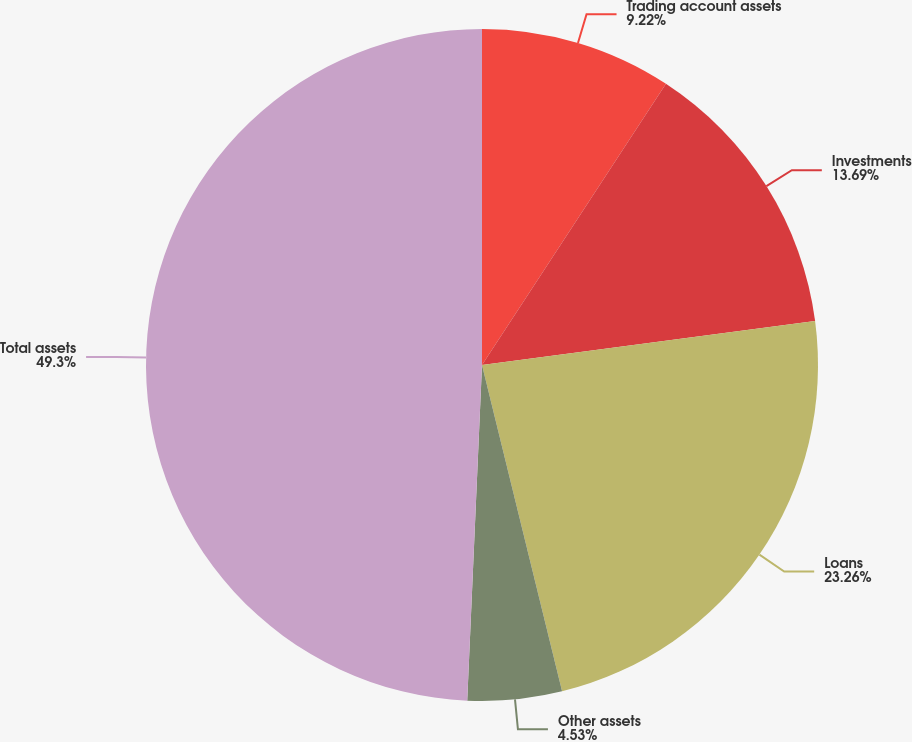Convert chart. <chart><loc_0><loc_0><loc_500><loc_500><pie_chart><fcel>Trading account assets<fcel>Investments<fcel>Loans<fcel>Other assets<fcel>Total assets<nl><fcel>9.22%<fcel>13.69%<fcel>23.26%<fcel>4.53%<fcel>49.3%<nl></chart> 